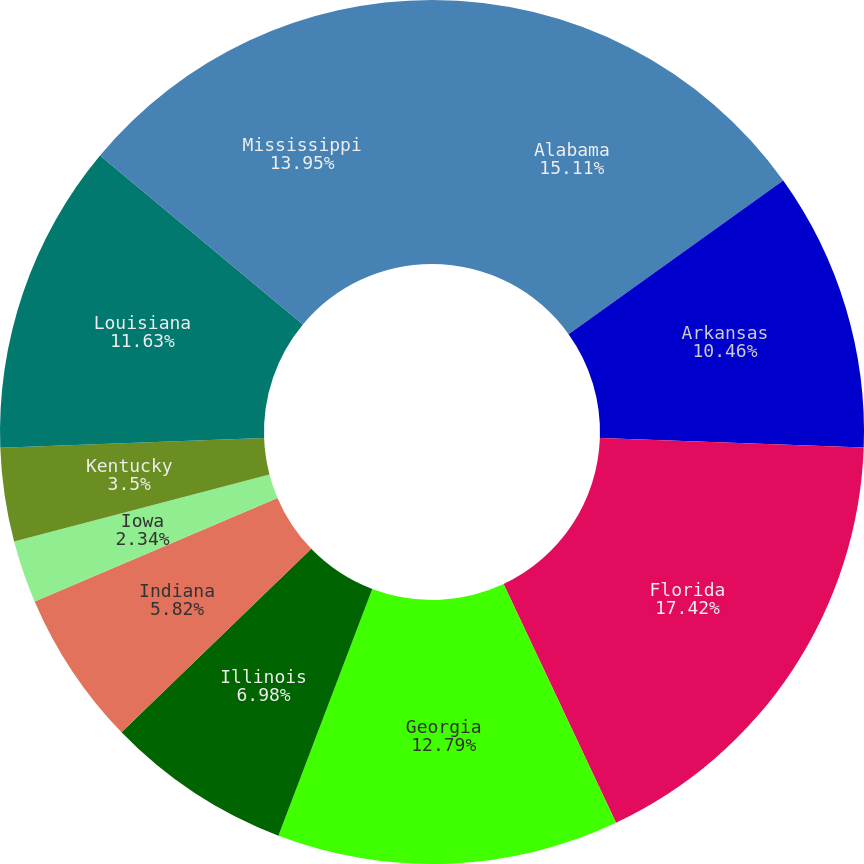<chart> <loc_0><loc_0><loc_500><loc_500><pie_chart><fcel>Alabama<fcel>Arkansas<fcel>Florida<fcel>Georgia<fcel>Illinois<fcel>Indiana<fcel>Iowa<fcel>Kentucky<fcel>Louisiana<fcel>Mississippi<nl><fcel>15.11%<fcel>10.46%<fcel>17.43%<fcel>12.79%<fcel>6.98%<fcel>5.82%<fcel>2.34%<fcel>3.5%<fcel>11.63%<fcel>13.95%<nl></chart> 